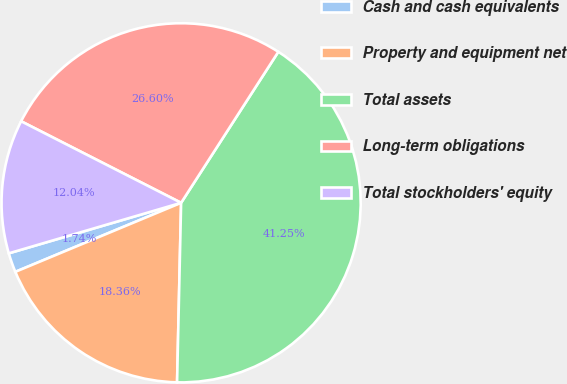Convert chart to OTSL. <chart><loc_0><loc_0><loc_500><loc_500><pie_chart><fcel>Cash and cash equivalents<fcel>Property and equipment net<fcel>Total assets<fcel>Long-term obligations<fcel>Total stockholders' equity<nl><fcel>1.74%<fcel>18.36%<fcel>41.25%<fcel>26.6%<fcel>12.04%<nl></chart> 